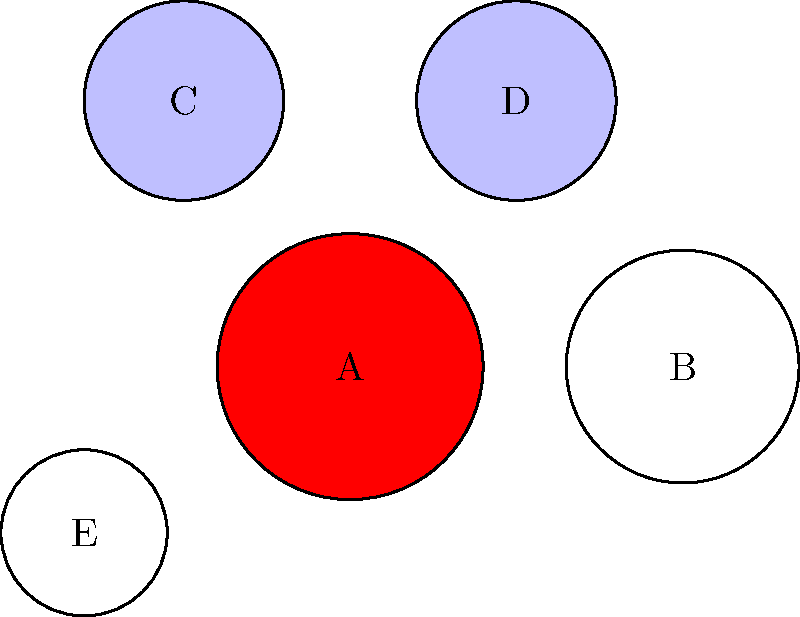In the blood smear image above, which cell type is represented by the structure labeled 'A'? To identify the cell type represented by structure 'A', let's analyze the characteristics of each cell in the image:

1. Cell A: Large, circular cell with a uniform red color.
2. Cell B: Slightly smaller than A, circular with a white or pale color.
3. Cells C and D: Smaller than A and B, circular with a pale blue color.
4. Cell E: The smallest cell, circular with a white or pale color.

Based on these observations:

1. The large red cell (A) is characteristic of a red blood cell (erythrocyte). Red blood cells are the most abundant cells in blood and appear as large, round cells with a reddish color due to the presence of hemoglobin.

2. The white or pale cells (B and E) likely represent different types of white blood cells (leukocytes).

3. The pale blue cells (C and D) could be other types of white blood cells or possibly platelets.

Given the size, shape, and distinctive red color, cell A is most consistent with a red blood cell or erythrocyte.
Answer: Red blood cell (erythrocyte) 